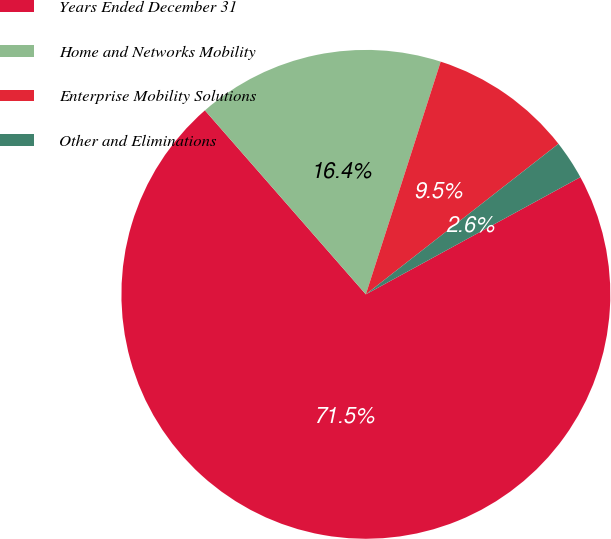Convert chart to OTSL. <chart><loc_0><loc_0><loc_500><loc_500><pie_chart><fcel>Years Ended December 31<fcel>Home and Networks Mobility<fcel>Enterprise Mobility Solutions<fcel>Other and Eliminations<nl><fcel>71.52%<fcel>16.39%<fcel>9.49%<fcel>2.6%<nl></chart> 